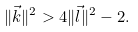<formula> <loc_0><loc_0><loc_500><loc_500>\| \vec { k } \| ^ { 2 } > 4 \| \vec { l } \| ^ { 2 } - 2 .</formula> 